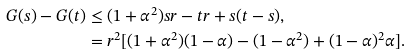Convert formula to latex. <formula><loc_0><loc_0><loc_500><loc_500>G ( s ) - G ( t ) & \leq ( 1 + \alpha ^ { 2 } ) s r - t r + s ( t - s ) , \\ & = r ^ { 2 } [ ( 1 + \alpha ^ { 2 } ) ( 1 - \alpha ) - ( 1 - \alpha ^ { 2 } ) + ( 1 - \alpha ) ^ { 2 } \alpha ] .</formula> 